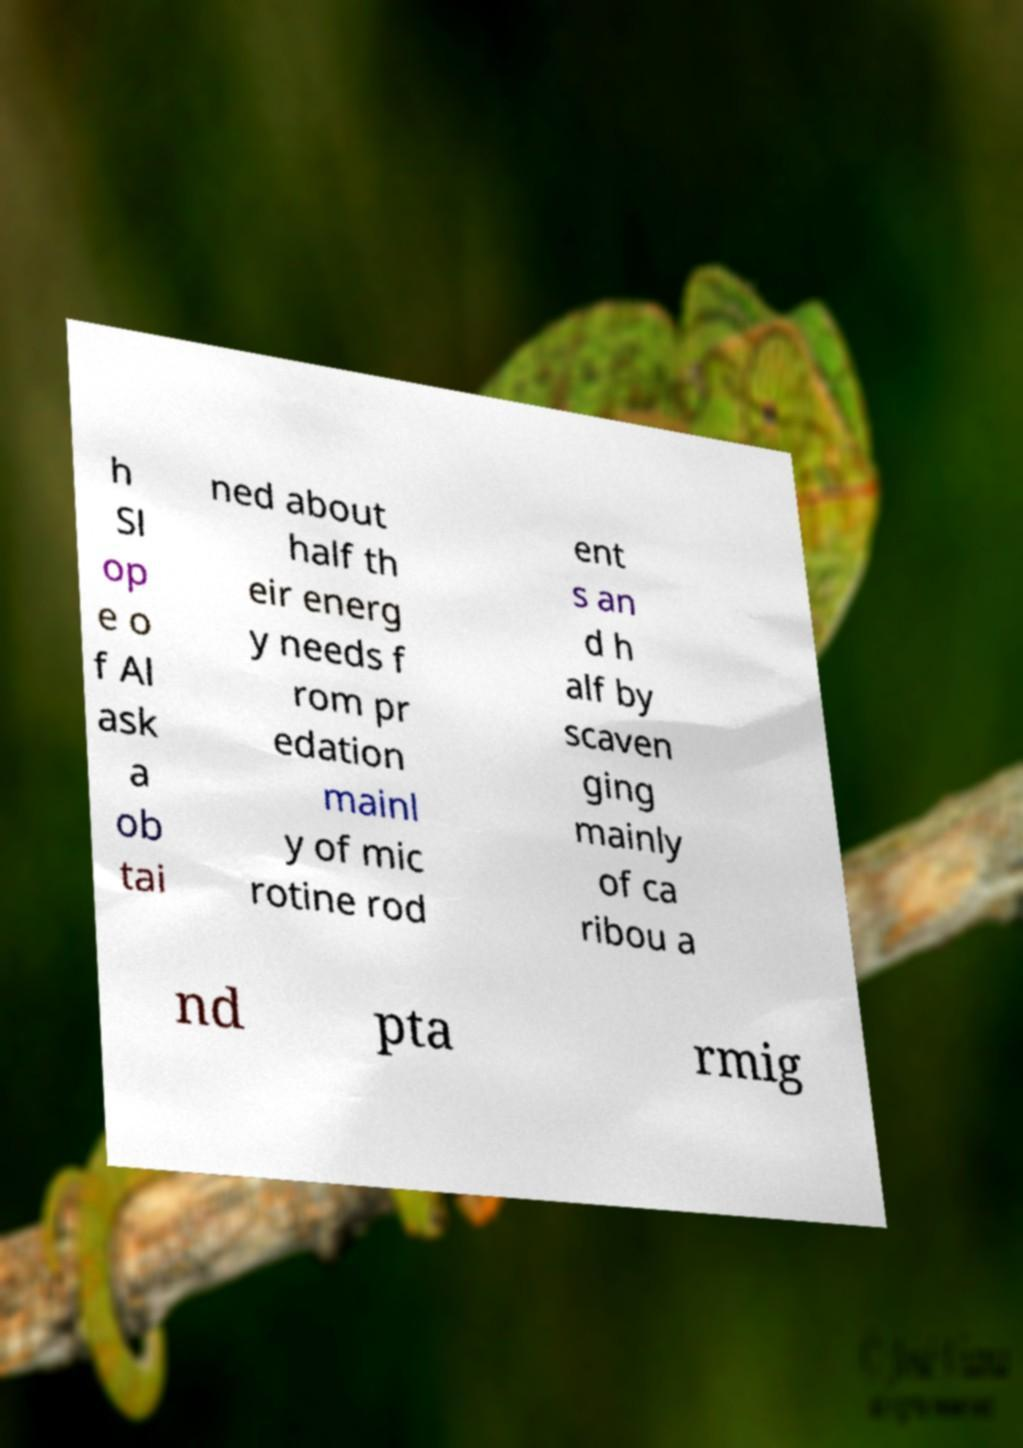For documentation purposes, I need the text within this image transcribed. Could you provide that? h Sl op e o f Al ask a ob tai ned about half th eir energ y needs f rom pr edation mainl y of mic rotine rod ent s an d h alf by scaven ging mainly of ca ribou a nd pta rmig 